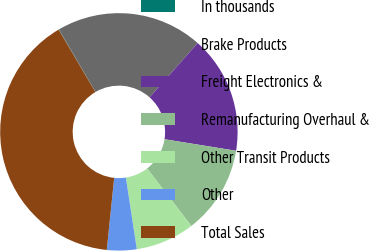Convert chart to OTSL. <chart><loc_0><loc_0><loc_500><loc_500><pie_chart><fcel>In thousands<fcel>Brake Products<fcel>Freight Electronics &<fcel>Remanufacturing Overhaul &<fcel>Other Transit Products<fcel>Other<fcel>Total Sales<nl><fcel>0.06%<fcel>19.98%<fcel>15.99%<fcel>12.01%<fcel>8.03%<fcel>4.04%<fcel>39.89%<nl></chart> 